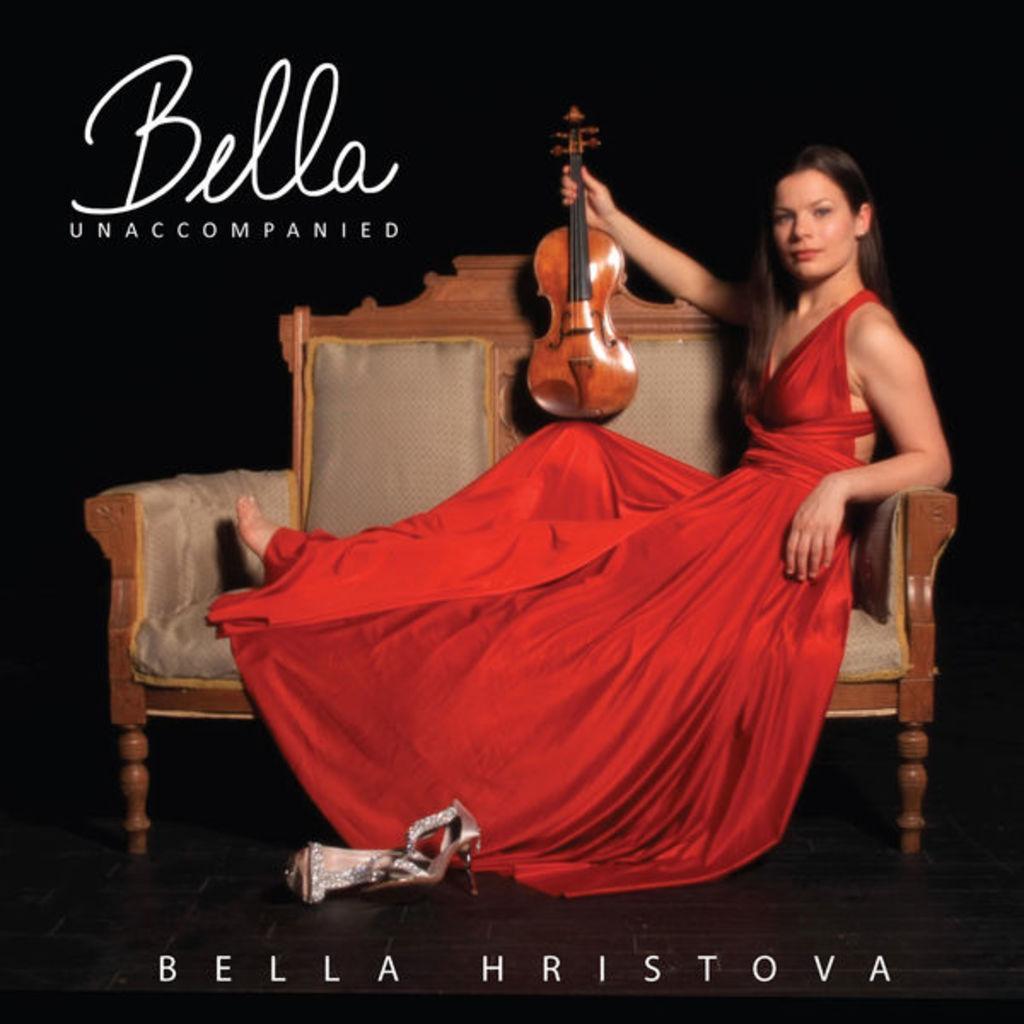In one or two sentences, can you explain what this image depicts? In this picture we can see a woman is sitting on the sofa and she is holding a violin, at the top and bottom of the image we can see some text. 